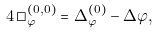<formula> <loc_0><loc_0><loc_500><loc_500>4 \, \square ^ { ( 0 , 0 ) } _ { \varphi } = \Delta _ { \varphi } ^ { ( 0 ) } - \Delta \varphi ,</formula> 